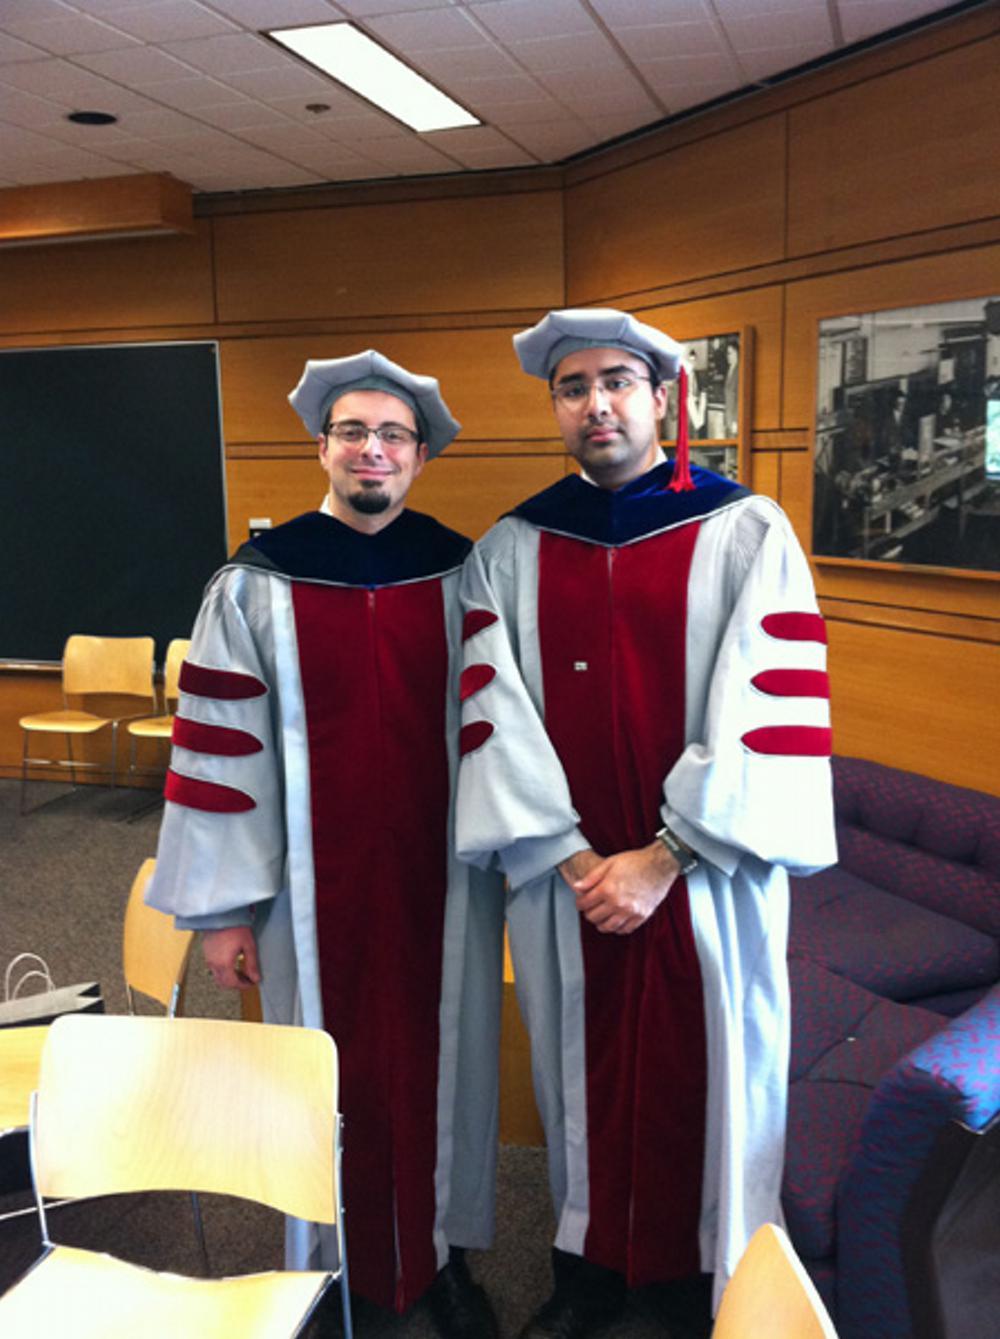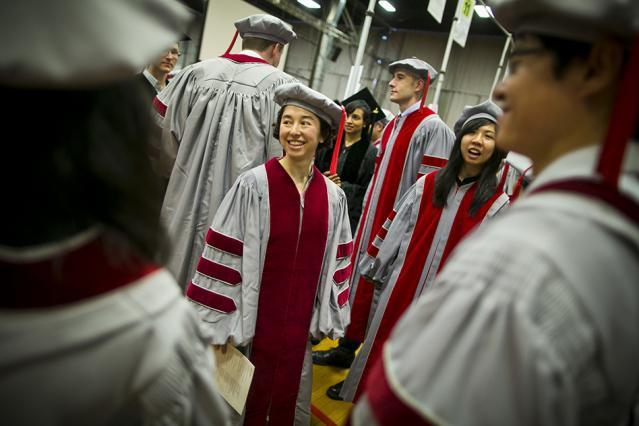The first image is the image on the left, the second image is the image on the right. Examine the images to the left and right. Is the description "An image includes in the foreground a black bearded man in a black robe and tasseled square cap near a white man in a gray robe and beret-type hat." accurate? Answer yes or no. No. 